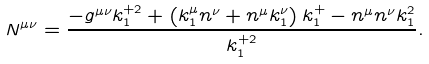<formula> <loc_0><loc_0><loc_500><loc_500>N ^ { \mu \nu } = \frac { - g ^ { \mu \nu } k _ { 1 } ^ { + 2 } + \left ( k _ { 1 } ^ { \mu } n ^ { \nu } + n ^ { \mu } k _ { 1 } ^ { \nu } \right ) k _ { 1 } ^ { + } - n ^ { \mu } n ^ { \nu } k _ { 1 } ^ { 2 } } { k _ { 1 } ^ { + 2 } } .</formula> 